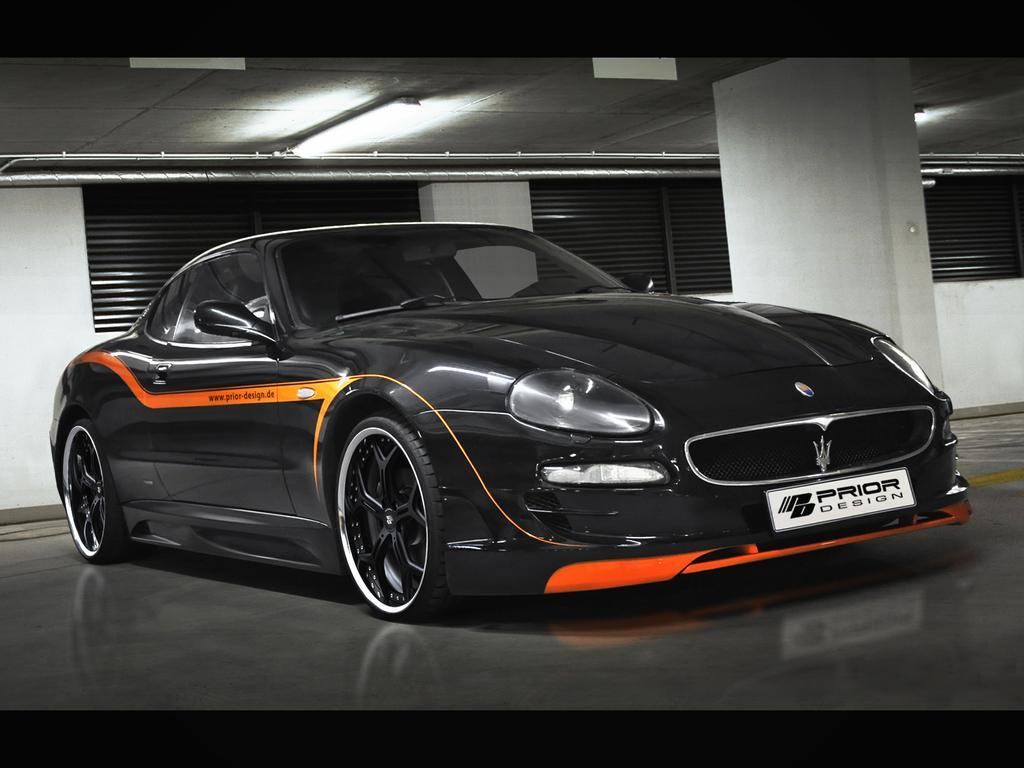What type of vehicle is in the image? There is a black car in the image. Where is the car located in the image? The car is parked on the floor. What can be seen behind the car in the image? There are windows on the wall behind the car. What is written on the number plate of the car? The number plate of the car has "PRIOR Design" written on it. What type of quiver is visible in the image? There is no quiver present in the image; it features a black car parked on the floor with windows on the wall behind it. 